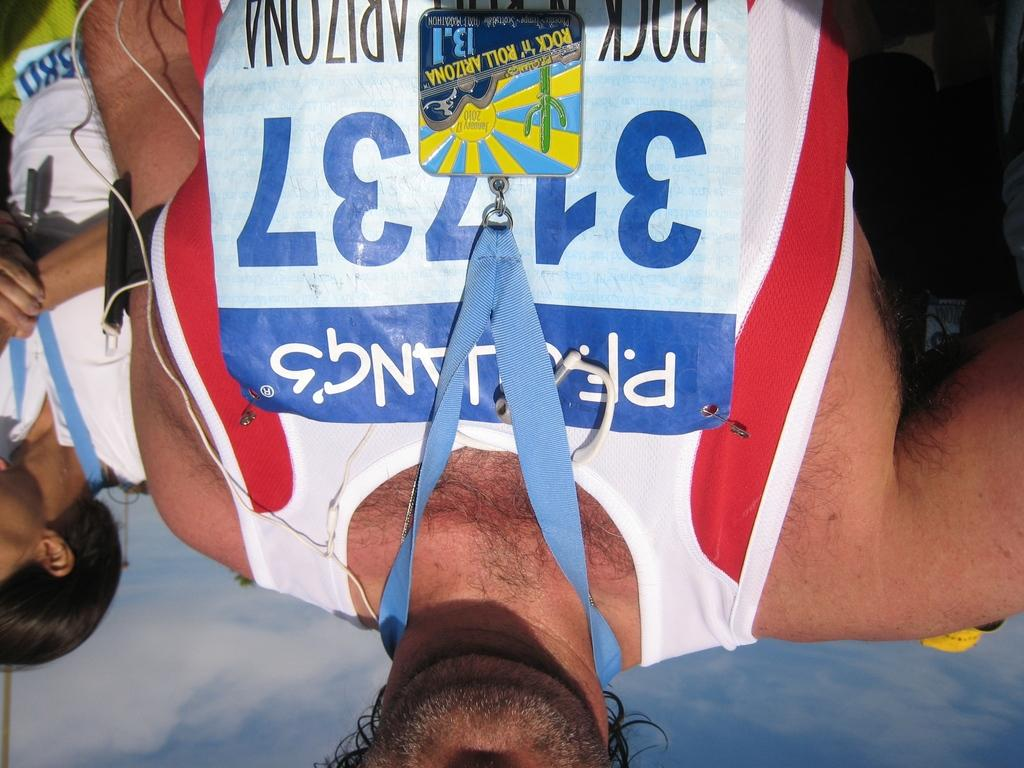Provide a one-sentence caption for the provided image. a man who ran a race, is wearing the number 31737. 